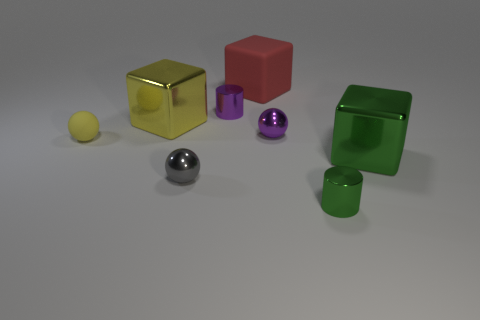Add 1 large red objects. How many objects exist? 9 Subtract all shiny blocks. How many blocks are left? 1 Subtract all gray balls. How many balls are left? 2 Subtract all spheres. How many objects are left? 5 Subtract 2 blocks. How many blocks are left? 1 Subtract all yellow blocks. Subtract all blue balls. How many blocks are left? 2 Subtract all purple cylinders. How many purple spheres are left? 1 Subtract all purple spheres. Subtract all tiny gray shiny things. How many objects are left? 6 Add 6 small gray shiny spheres. How many small gray shiny spheres are left? 7 Add 4 large red rubber cubes. How many large red rubber cubes exist? 5 